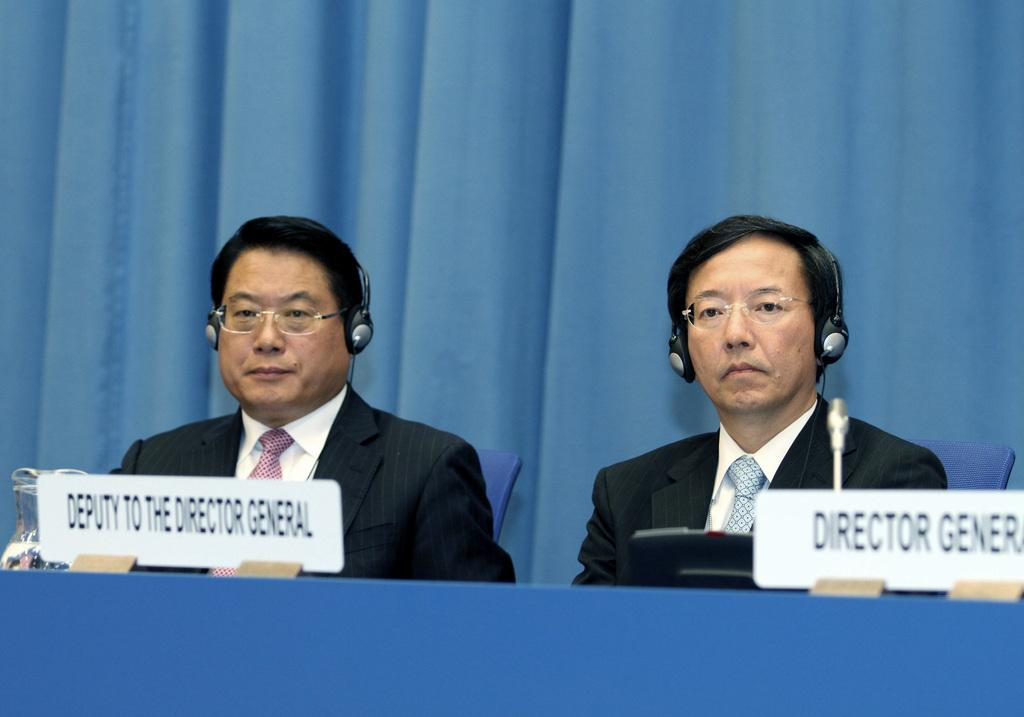<image>
Offer a succinct explanation of the picture presented. Two men, the deputy to the director general and the director general, sit behind a table. 